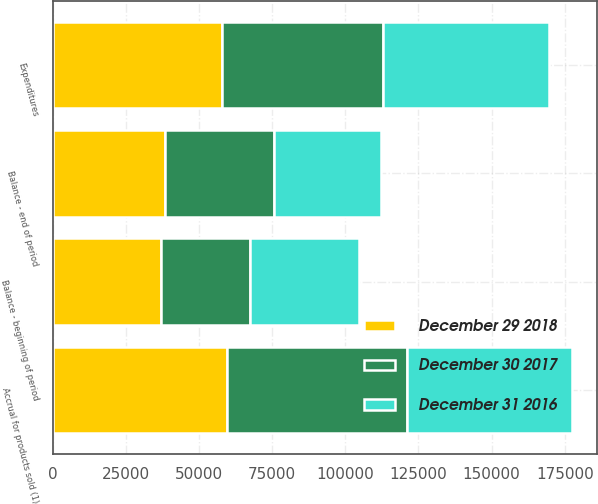Convert chart. <chart><loc_0><loc_0><loc_500><loc_500><stacked_bar_chart><ecel><fcel>Balance - beginning of period<fcel>Accrual for products sold (1)<fcel>Expenditures<fcel>Balance - end of period<nl><fcel>December 29 2018<fcel>36827<fcel>59374<fcel>57925<fcel>38276<nl><fcel>December 31 2016<fcel>37233<fcel>56360<fcel>56766<fcel>36827<nl><fcel>December 30 2017<fcel>30449<fcel>61578<fcel>54794<fcel>37233<nl></chart> 